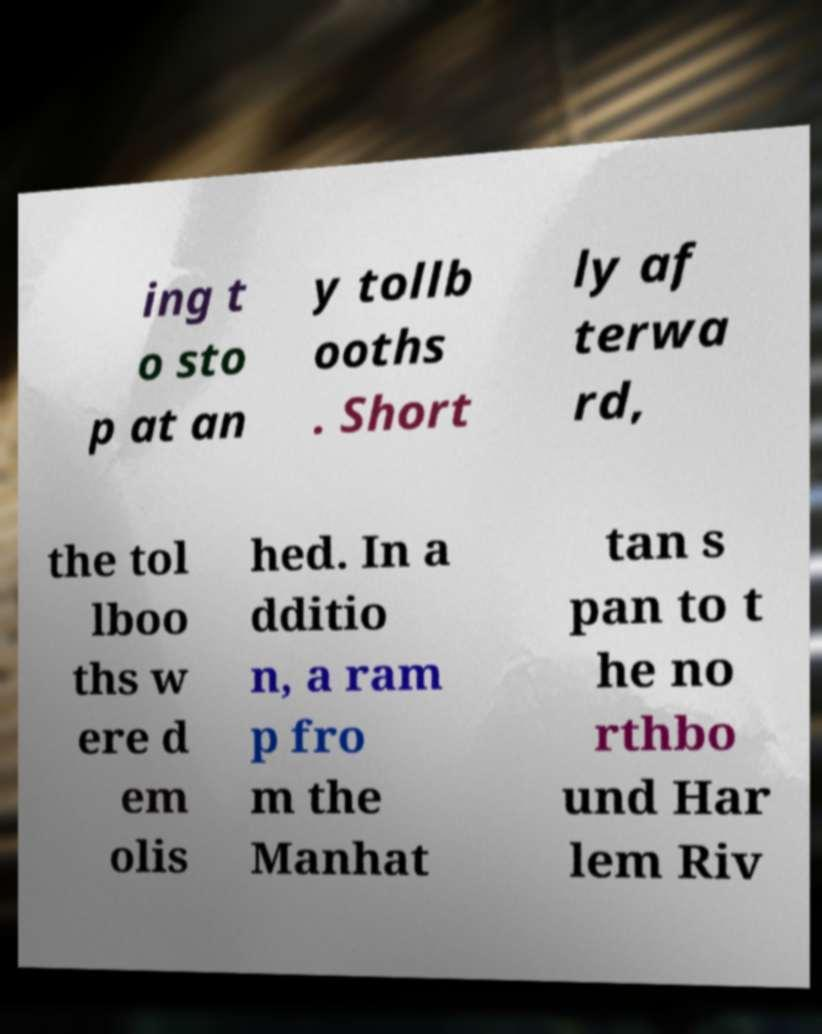Could you assist in decoding the text presented in this image and type it out clearly? ing t o sto p at an y tollb ooths . Short ly af terwa rd, the tol lboo ths w ere d em olis hed. In a dditio n, a ram p fro m the Manhat tan s pan to t he no rthbo und Har lem Riv 